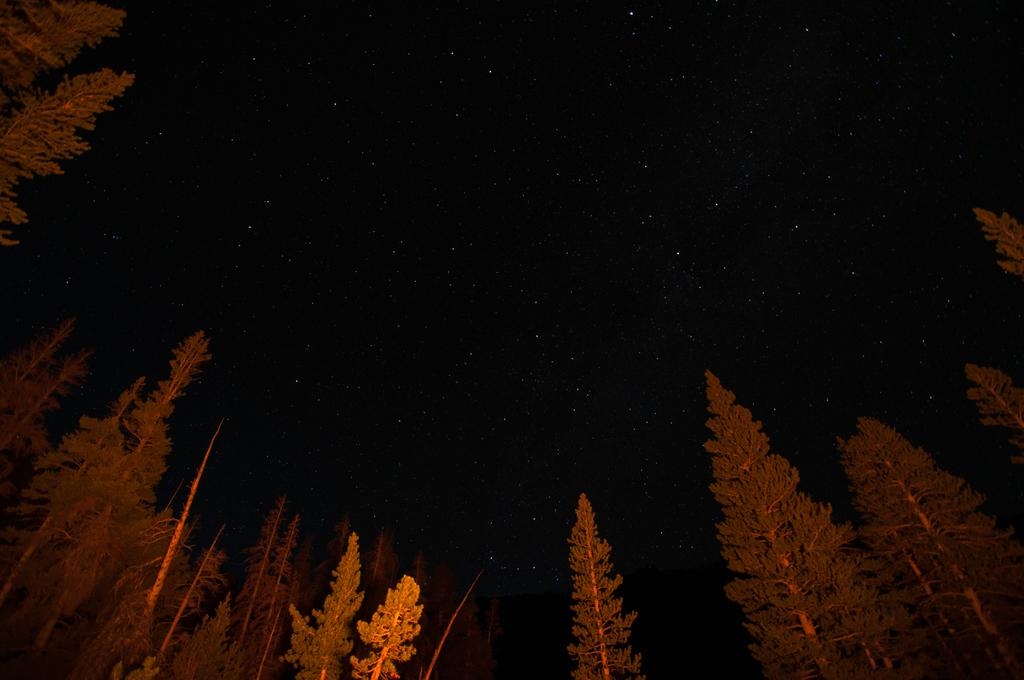What type of vegetation can be seen in the image? There are trees in the image. What part of the natural environment is visible in the image? The sky is visible in the image. What celestial objects can be seen in the sky? There are stars in the sky. What type of light is present in the image? There is a yellow color light in the image. Can you tell me how many tanks are running through the forest in the image? There are no tanks or running depicted in the image; it features trees, the sky, stars, and a yellow light. 